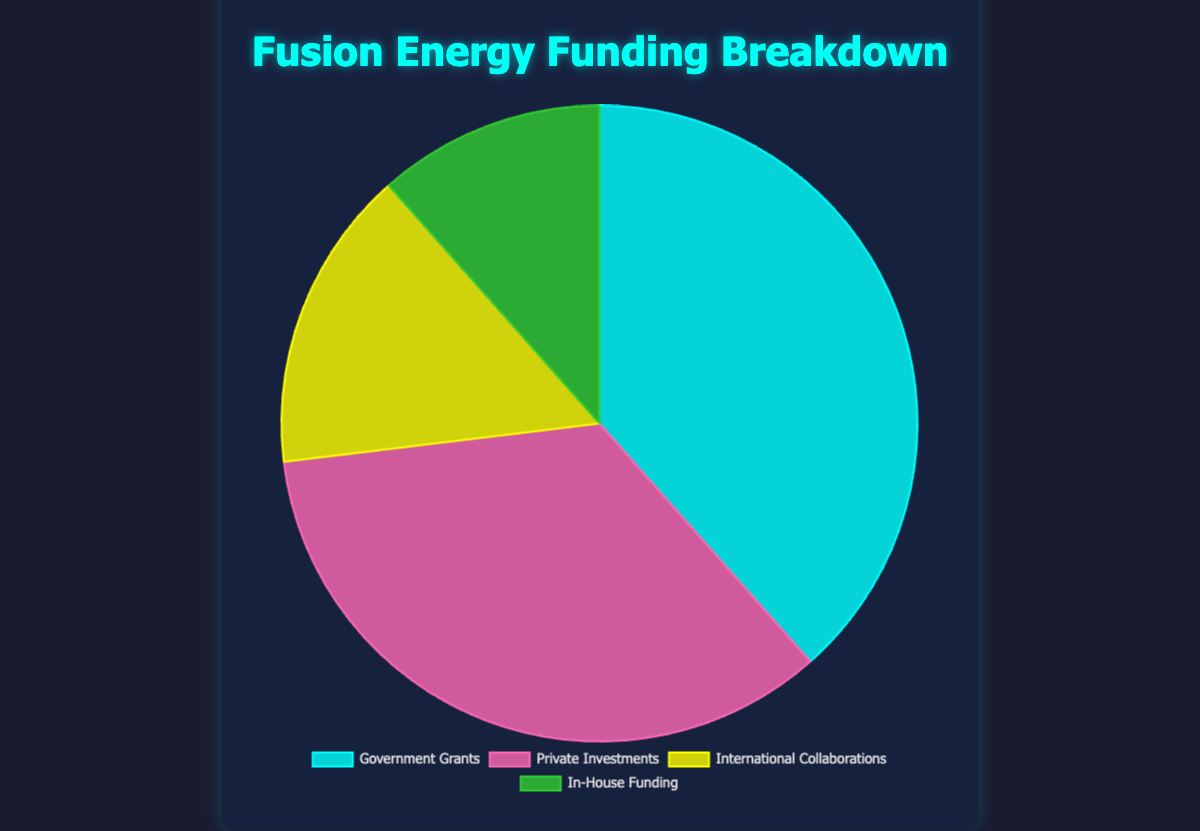What percentage of the funding comes from Government Grants? The chart shows that Government Grants account for one of the sections of the pie chart. This section sums up to 50%.
Answer: 50% Which funding source contributes the least to the total funding? Among the four segments of the pie chart, 'In-House Funding' represents the smallest section, highlighting it as the smallest contributor with 15%.
Answer: In-House Funding How much more is contributed by Government Grants compared to In-House Funding? Government Grants contribute 50%, and In-House Funding contributes 15%. The difference between them is 50% - 15%.
Answer: 35% What is the combined contribution of Private Investments and International Collaborations? Adding the contributions from Private Investments (45%) and International Collaborations (20%), we get 45% + 20%.
Answer: 65% Which two funding sources have the most similar contribution percentages? By comparing the segments of the pie chart, 'Private Investments' at 45% and 'Government Grants' at 50% are the closest in size.
Answer: Private Investments and Government Grants If In-House Funding grows by 5%, what will its new percentage be? In-House Funding is currently at 15%. An additional 5% means 15%+ 5% resulting in the new percentage.
Answer: 20% What color is used to represent International Collaborations? The chart displays each funding source with distinct colors. The segment representing International Collaborations is yellow.
Answer: Yellow What is the difference in funding between International Collaborations and In-House Funding? International Collaborations contribute 20%, and In-House Funding contributes 15%. The difference between them is 20% - 15%.
Answer: 5% What is the median percentage of the four funding sources? Arrange the percentages of the four funding sources in ascending order: 15%, 20%, 45%, 50%. The median is the average of the two middle values, (20% + 45%)/2.
Answer: 32.5% Which funding source is represented by the color green? Observing the pie chart, the green segment corresponds to In-House Funding.
Answer: In-House Funding 